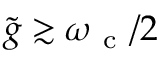<formula> <loc_0><loc_0><loc_500><loc_500>\tilde { g } \gtrsim \omega _ { c } / 2</formula> 